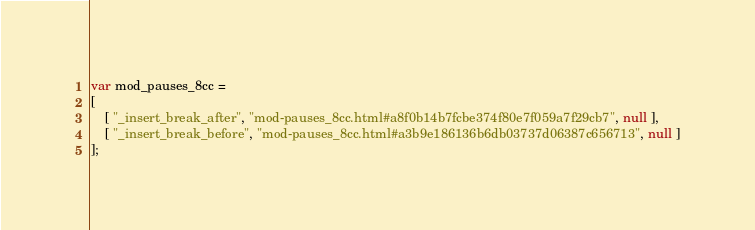Convert code to text. <code><loc_0><loc_0><loc_500><loc_500><_JavaScript_>var mod_pauses_8cc =
[
    [ "_insert_break_after", "mod-pauses_8cc.html#a8f0b14b7fcbe374f80e7f059a7f29cb7", null ],
    [ "_insert_break_before", "mod-pauses_8cc.html#a3b9e186136b6db03737d06387c656713", null ]
];</code> 